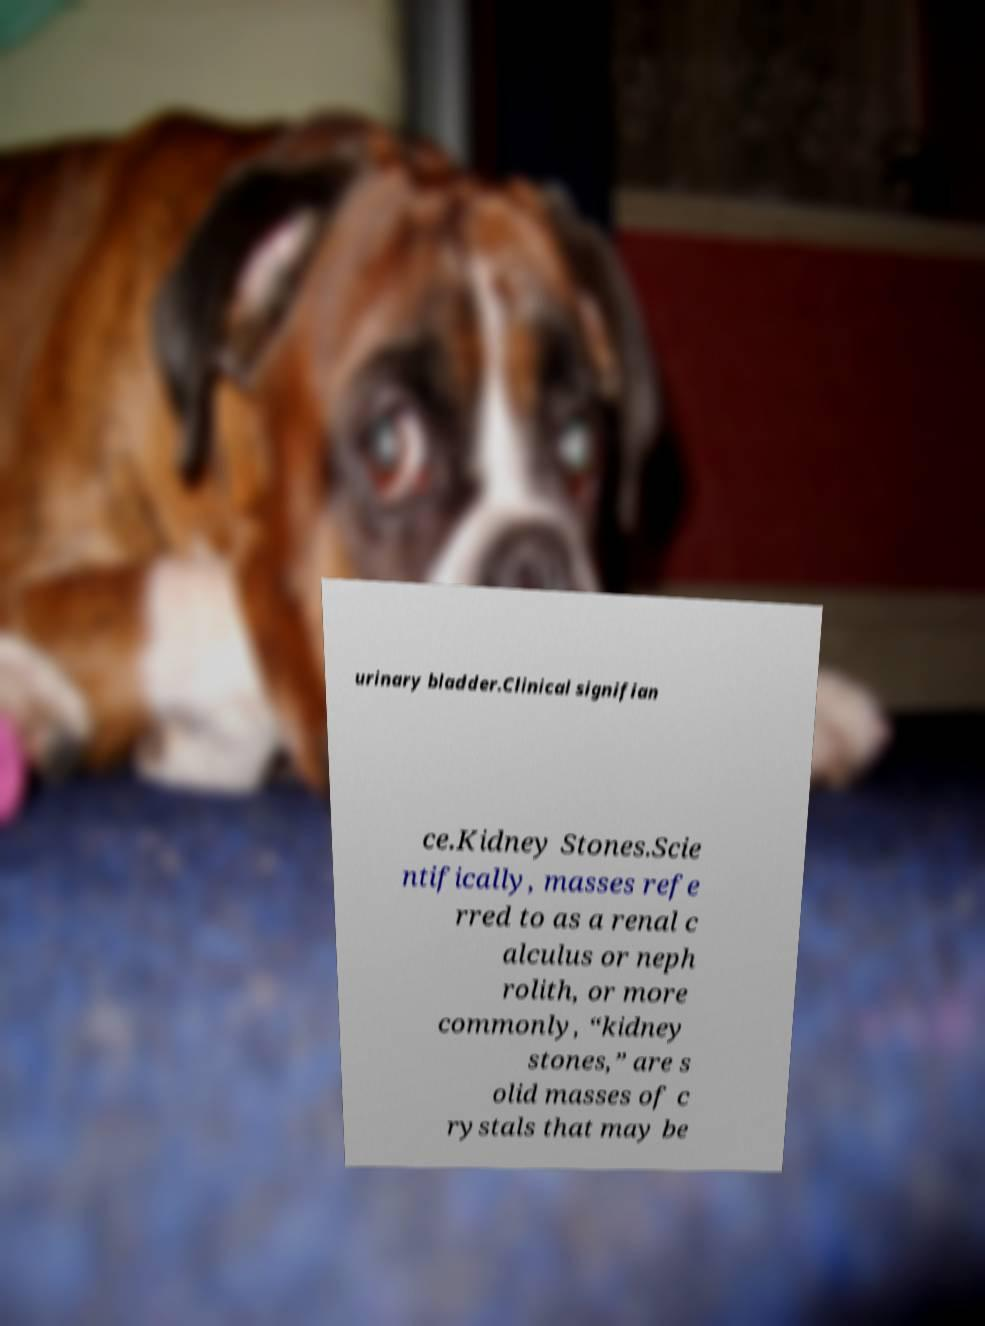Please read and relay the text visible in this image. What does it say? urinary bladder.Clinical signifian ce.Kidney Stones.Scie ntifically, masses refe rred to as a renal c alculus or neph rolith, or more commonly, “kidney stones,” are s olid masses of c rystals that may be 